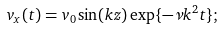<formula> <loc_0><loc_0><loc_500><loc_500>v _ { x } ( t ) = v _ { 0 } \sin ( k z ) \exp \{ - \nu k ^ { 2 } t \} ;</formula> 